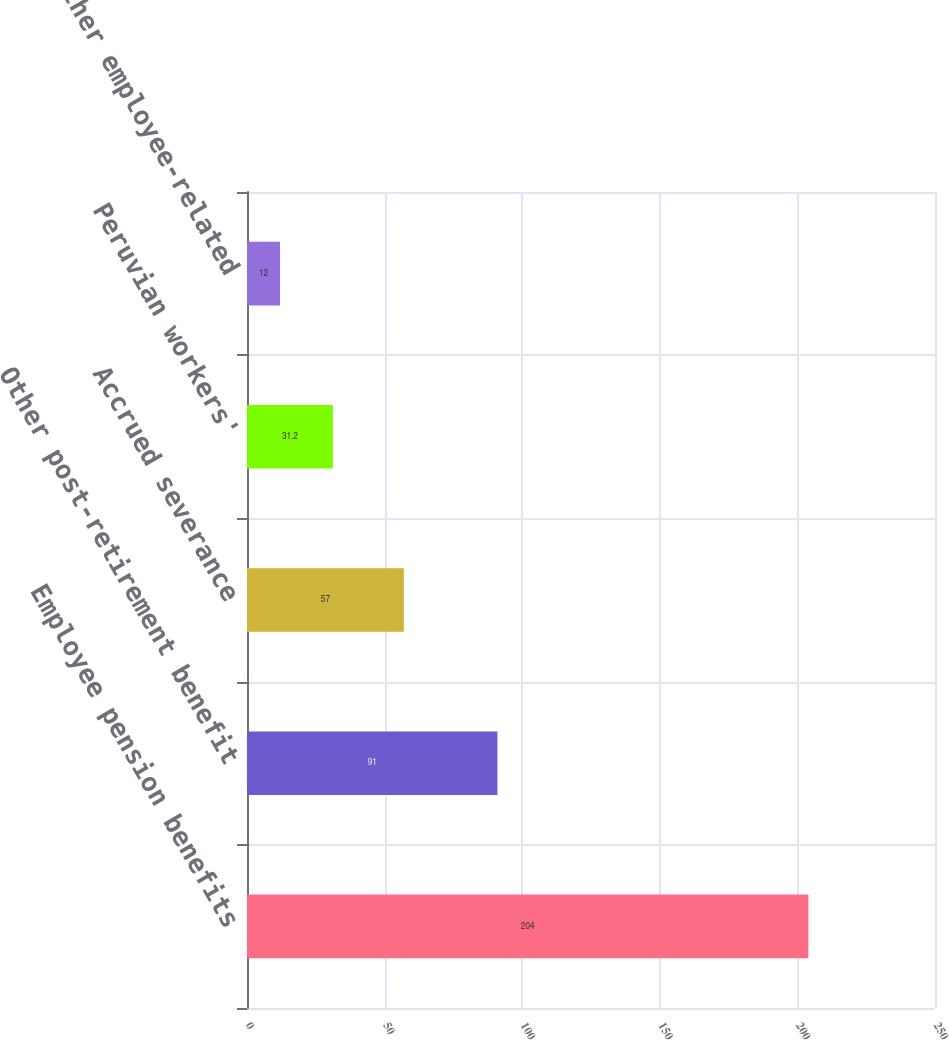<chart> <loc_0><loc_0><loc_500><loc_500><bar_chart><fcel>Employee pension benefits<fcel>Other post-retirement benefit<fcel>Accrued severance<fcel>Peruvian workers'<fcel>Other employee-related<nl><fcel>204<fcel>91<fcel>57<fcel>31.2<fcel>12<nl></chart> 